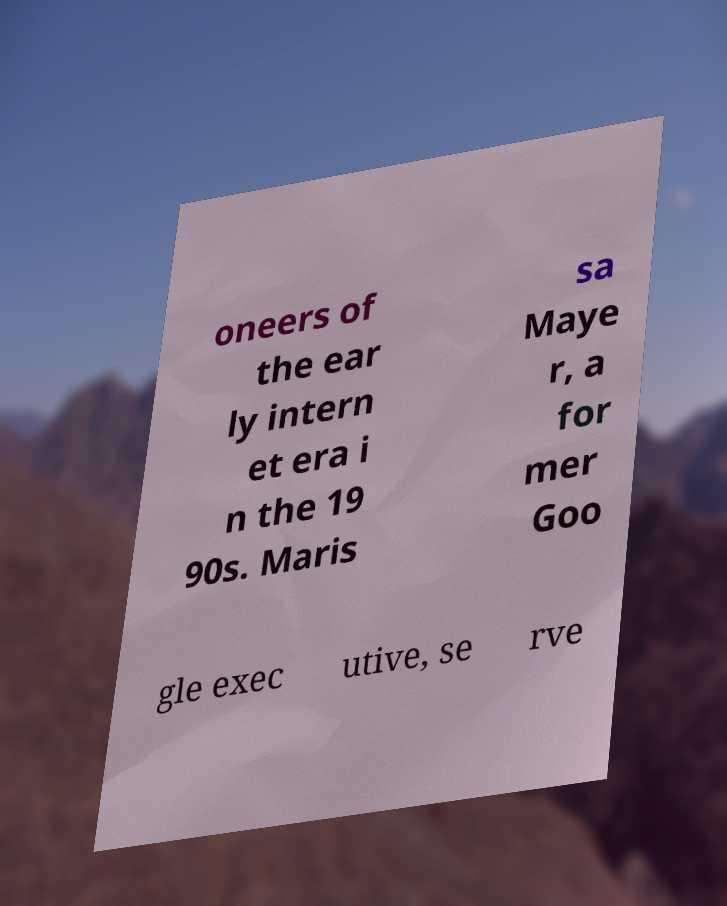Could you extract and type out the text from this image? oneers of the ear ly intern et era i n the 19 90s. Maris sa Maye r, a for mer Goo gle exec utive, se rve 